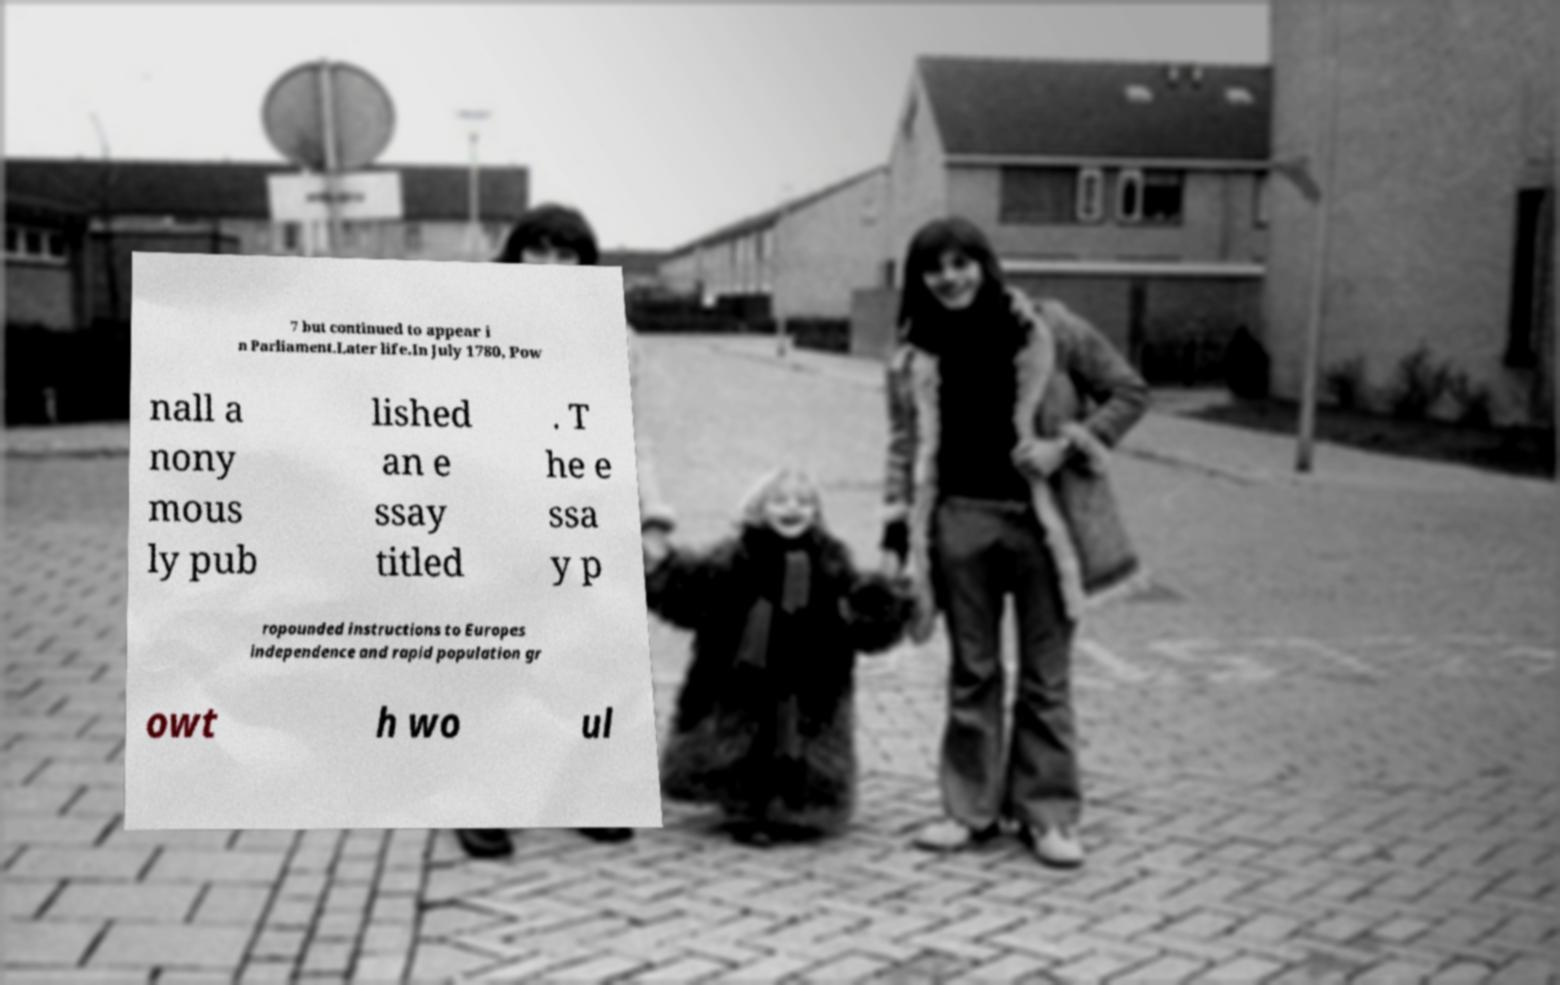Can you accurately transcribe the text from the provided image for me? 7 but continued to appear i n Parliament.Later life.In July 1780, Pow nall a nony mous ly pub lished an e ssay titled . T he e ssa y p ropounded instructions to Europes independence and rapid population gr owt h wo ul 